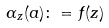<formula> <loc_0><loc_0><loc_500><loc_500>\alpha _ { z } ( a ) \colon = f ( z )</formula> 